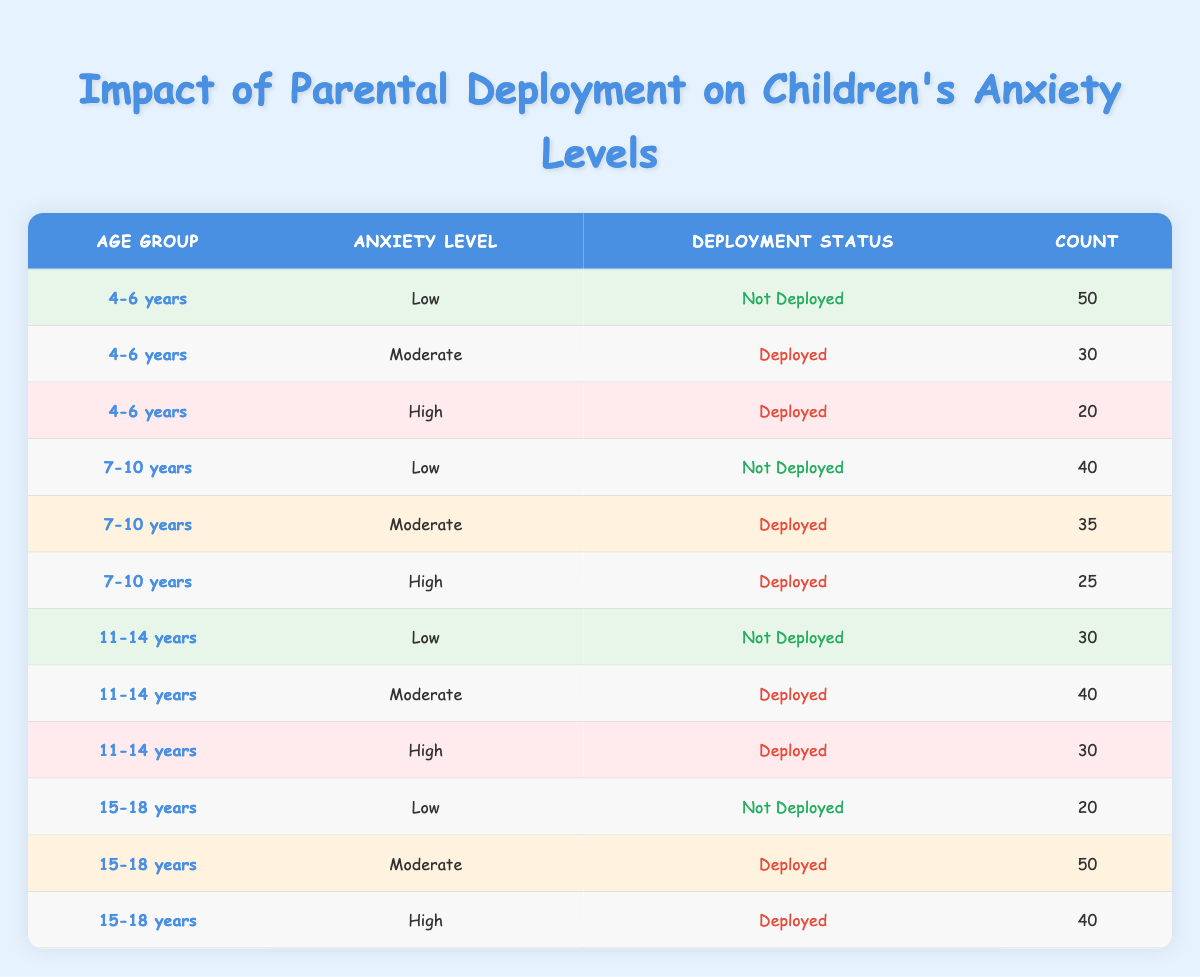What is the count of children aged 4-6 years who have low anxiety levels and are not deployed? From the table, we can see that for the age group 4-6 years and anxiety level Low, the deployment status is Not Deployed, and the count is listed as 50. Therefore, 50 children fit this criterion.
Answer: 50 How many children aged 7-10 years experience high anxiety levels while their parents are deployed? For the age group 7-10 years and anxiety level High, we check the deployment status Deployed, where the count indicates that 25 children experience that level of anxiety.
Answer: 25 Is there a higher count of children aged 11-14 years with moderate anxiety levels when parents are deployed or not deployed? The table shows that for the age group 11-14 years, the count for Moderate anxiety with Deployed status is 40 and for Not Deployed status is 30. Since 40 is greater than 30, the higher count is in the deployed category.
Answer: Yes What is the total count of children aged 15-18 years with high anxiety levels? The table shows that for the age group 15-18 years, the count for High anxiety is 40 for Deployed status and 20 for Not Deployed status. Adding these counts together gives us 40 + 20 = 60.
Answer: 60 Among all age groups, which age group has the highest count of children with low anxiety levels, and what is that count? Looking at the table, the counts for Low anxiety levels are 50 for age group 4-6 years, 40 for 7-10 years, 30 for 11-14 years, and 20 for 15-18 years. The highest is 50 in the 4-6 years age group.
Answer: 4-6 years, 50 What is the average count of children experiencing moderate anxiety levels across all age groups? The table shows counts for Moderate anxiety levels as follows: 30 (4-6 years), 35 (7-10 years), 40 (11-14 years), and 50 (15-18 years). Summing these gives 30 + 35 + 40 + 50 = 155. There are 4 age groups, so the average is 155 / 4 = 38.75.
Answer: 38.75 Are there more children with low anxiety levels across all age groups than those with high anxiety levels? The total count of Low anxiety levels is 50 (4-6 years) + 40 (7-10 years) + 30 (11-14 years) + 20 (15-18 years) = 140. The count for High anxiety levels is 20 (4-6 years) + 25 (7-10 years) + 30 (11-14 years) + 40 (15-18 years) = 115. Since 140 > 115, there are indeed more children with Low anxiety levels.
Answer: Yes What is the difference in count between children aged 11-14 years experiencing moderate anxiety levels versus those with high anxiety levels while their parents are deployed? According to the table, for the age group 11-14 years, the count for Moderate anxiety levels when Deployed is 40 and for High anxiety levels when Deployed is 30. The difference is 40 - 30 = 10.
Answer: 10 In which age group is the anxiety level of children most likely to be moderate when their parents are deployed? Analyzing the counts for Moderate anxiety when Deployed: 30 for 4-6 years, 35 for 7-10 years, 40 for 11-14 years, and 50 for 15-18 years. The highest count is 50 in the 15-18 years age group, indicating it's the most likely age group to experience this anxiety level when parents are deployed.
Answer: 15-18 years 